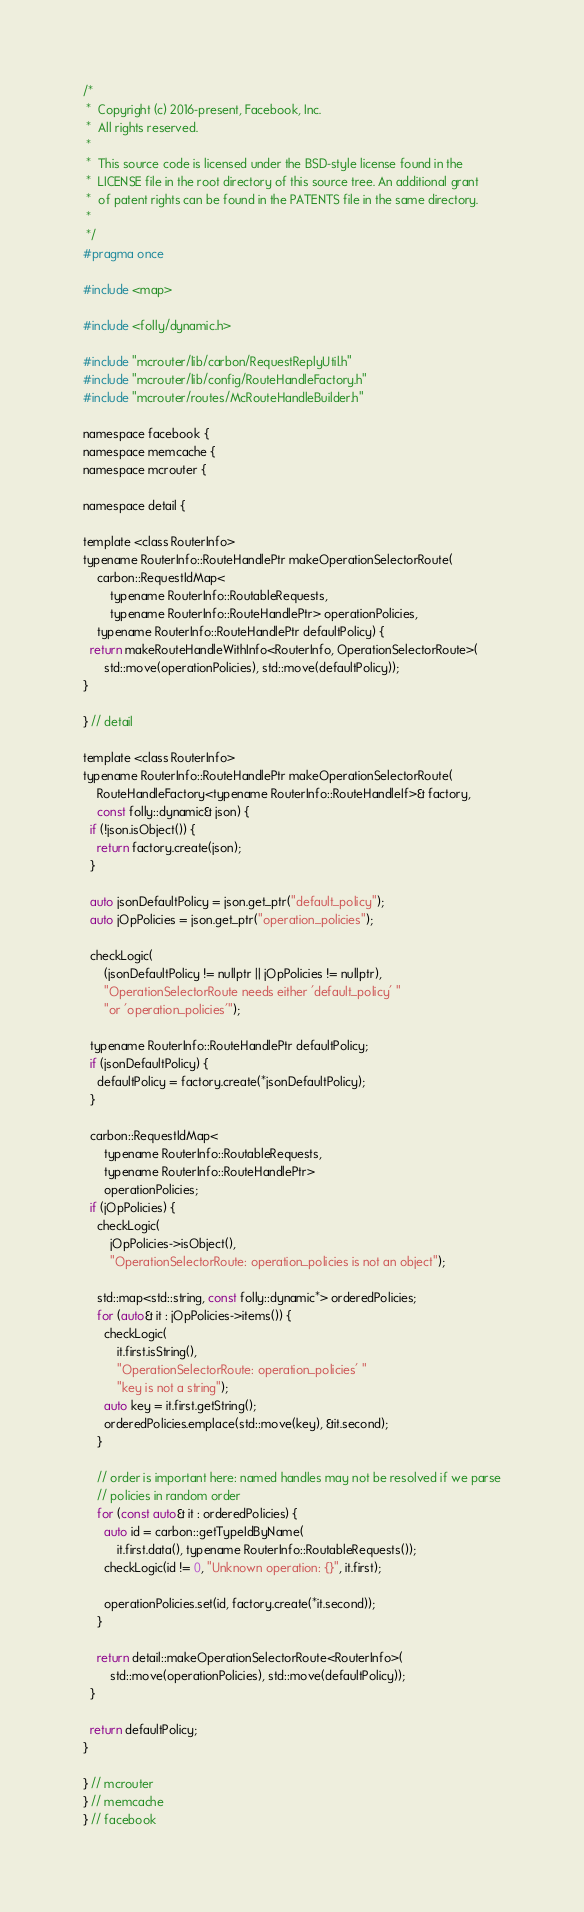<code> <loc_0><loc_0><loc_500><loc_500><_C_>/*
 *  Copyright (c) 2016-present, Facebook, Inc.
 *  All rights reserved.
 *
 *  This source code is licensed under the BSD-style license found in the
 *  LICENSE file in the root directory of this source tree. An additional grant
 *  of patent rights can be found in the PATENTS file in the same directory.
 *
 */
#pragma once

#include <map>

#include <folly/dynamic.h>

#include "mcrouter/lib/carbon/RequestReplyUtil.h"
#include "mcrouter/lib/config/RouteHandleFactory.h"
#include "mcrouter/routes/McRouteHandleBuilder.h"

namespace facebook {
namespace memcache {
namespace mcrouter {

namespace detail {

template <class RouterInfo>
typename RouterInfo::RouteHandlePtr makeOperationSelectorRoute(
    carbon::RequestIdMap<
        typename RouterInfo::RoutableRequests,
        typename RouterInfo::RouteHandlePtr> operationPolicies,
    typename RouterInfo::RouteHandlePtr defaultPolicy) {
  return makeRouteHandleWithInfo<RouterInfo, OperationSelectorRoute>(
      std::move(operationPolicies), std::move(defaultPolicy));
}

} // detail

template <class RouterInfo>
typename RouterInfo::RouteHandlePtr makeOperationSelectorRoute(
    RouteHandleFactory<typename RouterInfo::RouteHandleIf>& factory,
    const folly::dynamic& json) {
  if (!json.isObject()) {
    return factory.create(json);
  }

  auto jsonDefaultPolicy = json.get_ptr("default_policy");
  auto jOpPolicies = json.get_ptr("operation_policies");

  checkLogic(
      (jsonDefaultPolicy != nullptr || jOpPolicies != nullptr),
      "OperationSelectorRoute needs either 'default_policy' "
      "or 'operation_policies'");

  typename RouterInfo::RouteHandlePtr defaultPolicy;
  if (jsonDefaultPolicy) {
    defaultPolicy = factory.create(*jsonDefaultPolicy);
  }

  carbon::RequestIdMap<
      typename RouterInfo::RoutableRequests,
      typename RouterInfo::RouteHandlePtr>
      operationPolicies;
  if (jOpPolicies) {
    checkLogic(
        jOpPolicies->isObject(),
        "OperationSelectorRoute: operation_policies is not an object");

    std::map<std::string, const folly::dynamic*> orderedPolicies;
    for (auto& it : jOpPolicies->items()) {
      checkLogic(
          it.first.isString(),
          "OperationSelectorRoute: operation_policies' "
          "key is not a string");
      auto key = it.first.getString();
      orderedPolicies.emplace(std::move(key), &it.second);
    }

    // order is important here: named handles may not be resolved if we parse
    // policies in random order
    for (const auto& it : orderedPolicies) {
      auto id = carbon::getTypeIdByName(
          it.first.data(), typename RouterInfo::RoutableRequests());
      checkLogic(id != 0, "Unknown operation: {}", it.first);

      operationPolicies.set(id, factory.create(*it.second));
    }

    return detail::makeOperationSelectorRoute<RouterInfo>(
        std::move(operationPolicies), std::move(defaultPolicy));
  }

  return defaultPolicy;
}

} // mcrouter
} // memcache
} // facebook
</code> 